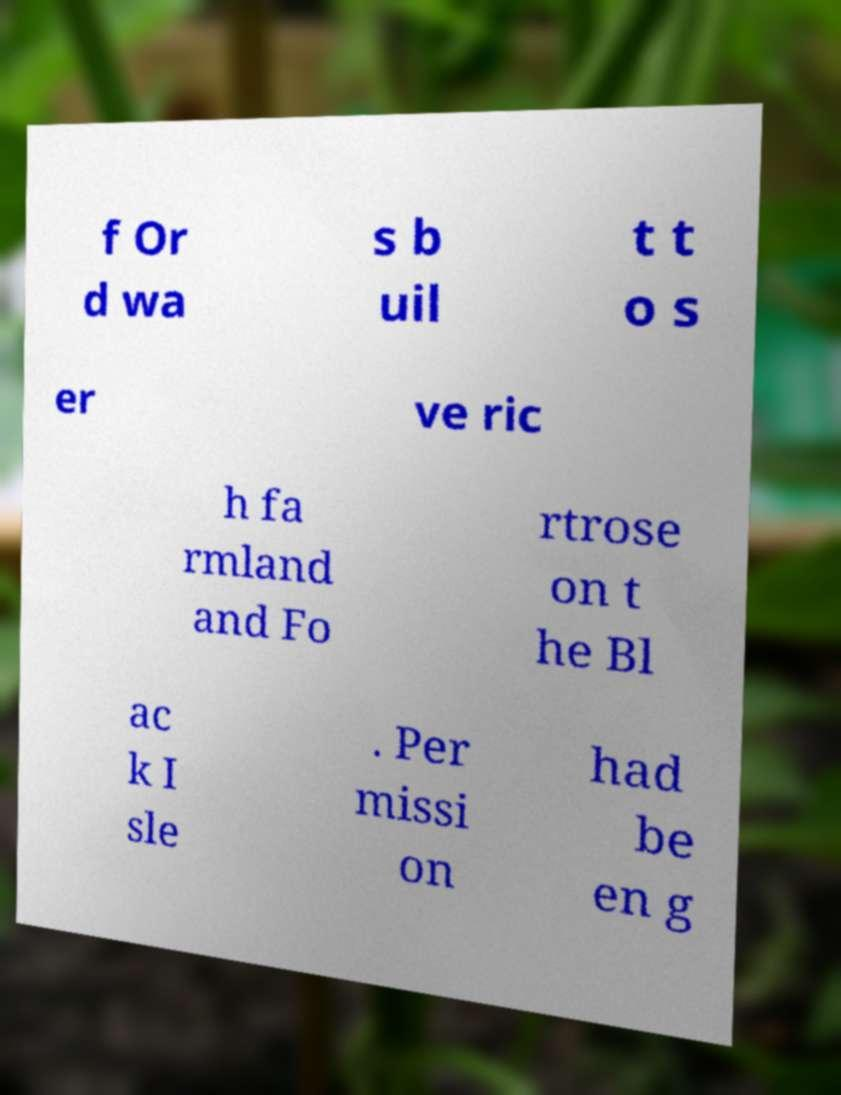I need the written content from this picture converted into text. Can you do that? f Or d wa s b uil t t o s er ve ric h fa rmland and Fo rtrose on t he Bl ac k I sle . Per missi on had be en g 